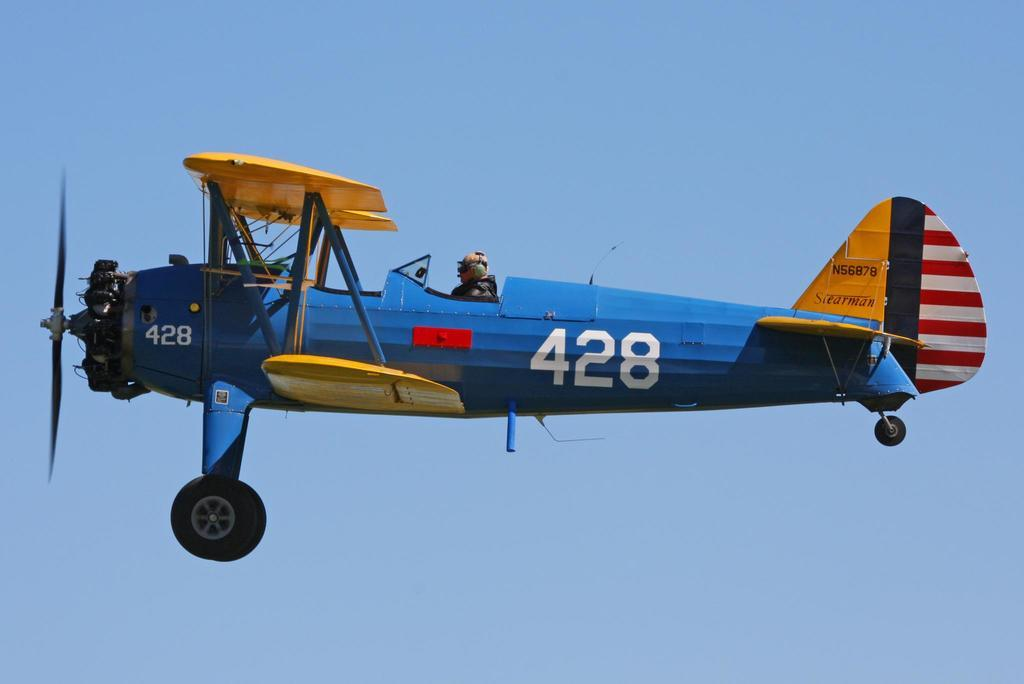What is the main subject of the image? The main subject of the image is a person in an airplane. What is the location of the airplane? The airplane is in the air. What can be seen in the background of the image? The sky is visible in the background of the image. What type of sock is the person wearing in the image? There is no information about the person's socks in the image, so it cannot be determined. 